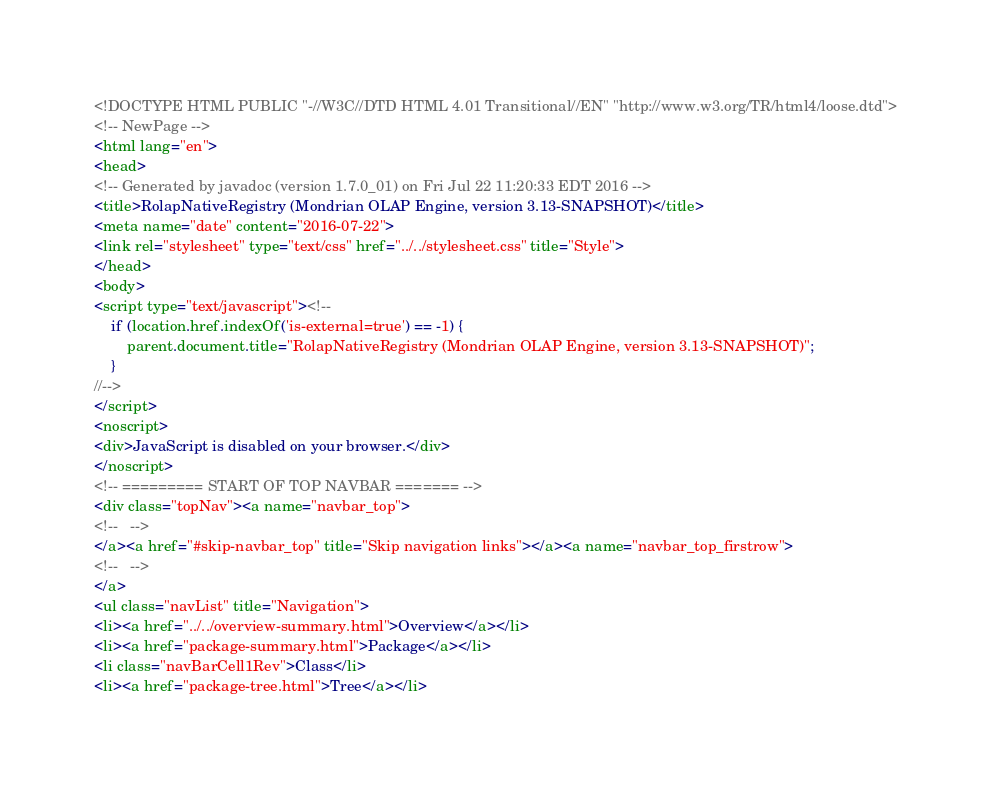Convert code to text. <code><loc_0><loc_0><loc_500><loc_500><_HTML_><!DOCTYPE HTML PUBLIC "-//W3C//DTD HTML 4.01 Transitional//EN" "http://www.w3.org/TR/html4/loose.dtd">
<!-- NewPage -->
<html lang="en">
<head>
<!-- Generated by javadoc (version 1.7.0_01) on Fri Jul 22 11:20:33 EDT 2016 -->
<title>RolapNativeRegistry (Mondrian OLAP Engine, version 3.13-SNAPSHOT)</title>
<meta name="date" content="2016-07-22">
<link rel="stylesheet" type="text/css" href="../../stylesheet.css" title="Style">
</head>
<body>
<script type="text/javascript"><!--
    if (location.href.indexOf('is-external=true') == -1) {
        parent.document.title="RolapNativeRegistry (Mondrian OLAP Engine, version 3.13-SNAPSHOT)";
    }
//-->
</script>
<noscript>
<div>JavaScript is disabled on your browser.</div>
</noscript>
<!-- ========= START OF TOP NAVBAR ======= -->
<div class="topNav"><a name="navbar_top">
<!--   -->
</a><a href="#skip-navbar_top" title="Skip navigation links"></a><a name="navbar_top_firstrow">
<!--   -->
</a>
<ul class="navList" title="Navigation">
<li><a href="../../overview-summary.html">Overview</a></li>
<li><a href="package-summary.html">Package</a></li>
<li class="navBarCell1Rev">Class</li>
<li><a href="package-tree.html">Tree</a></li></code> 